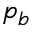Convert formula to latex. <formula><loc_0><loc_0><loc_500><loc_500>p _ { b }</formula> 